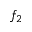Convert formula to latex. <formula><loc_0><loc_0><loc_500><loc_500>f _ { 2 }</formula> 